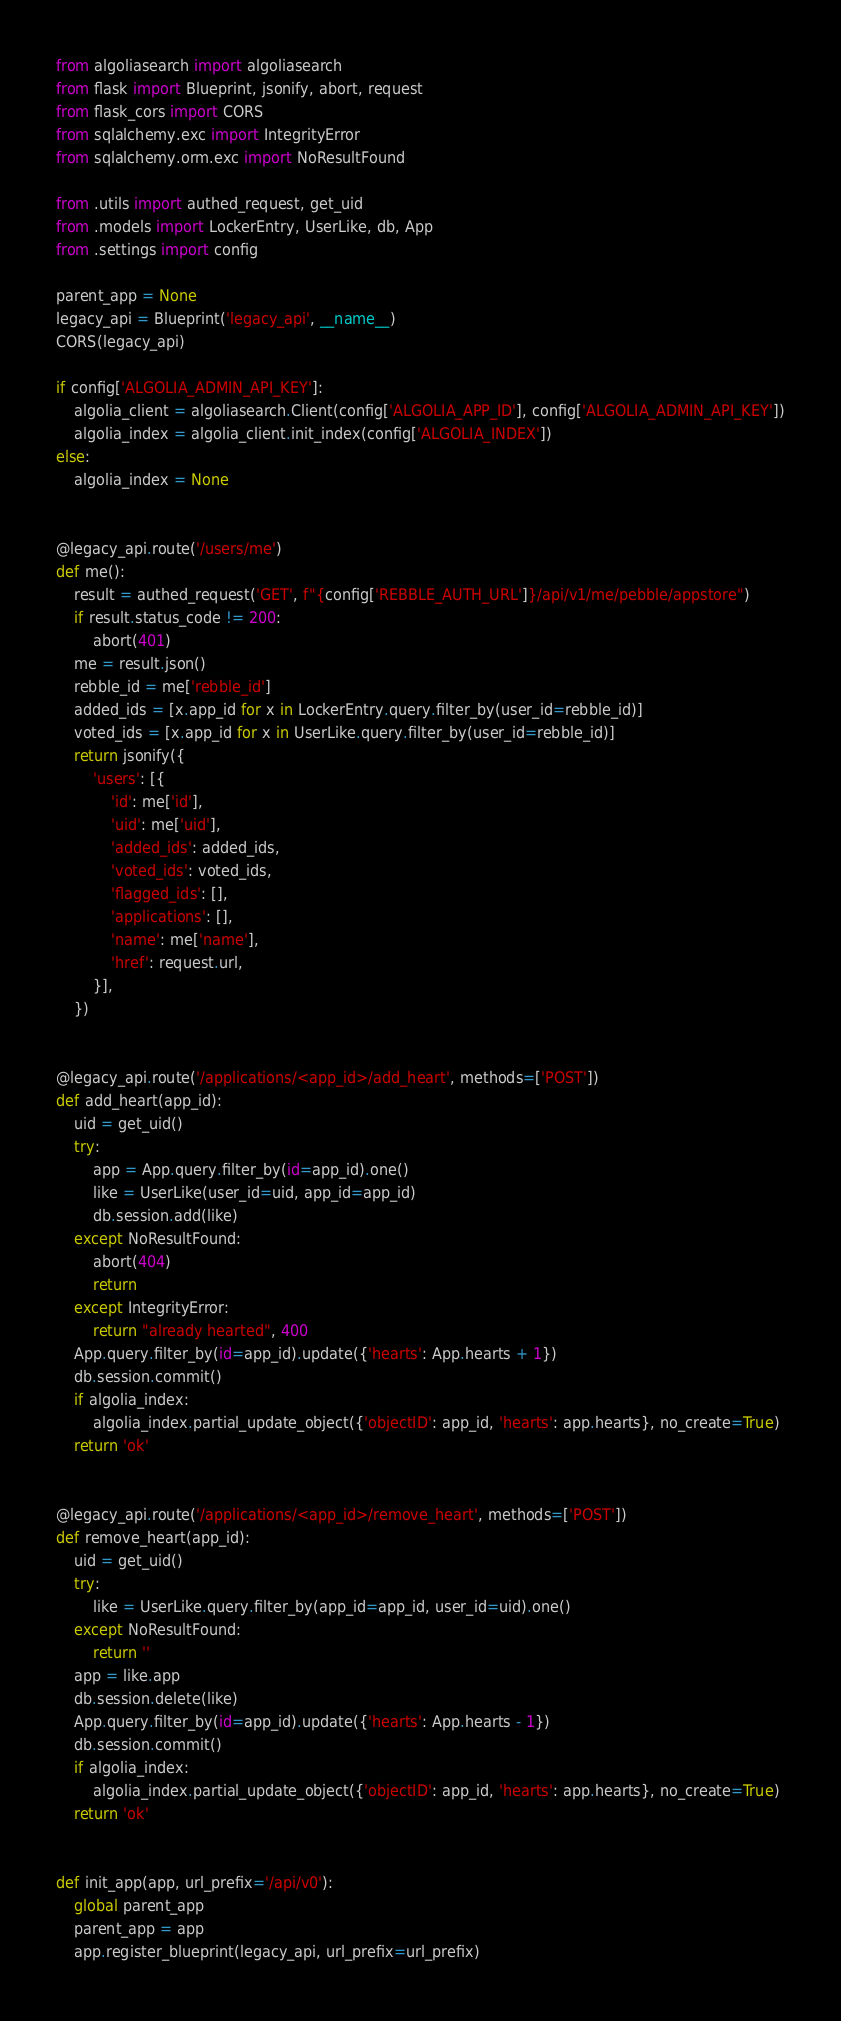<code> <loc_0><loc_0><loc_500><loc_500><_Python_>from algoliasearch import algoliasearch
from flask import Blueprint, jsonify, abort, request
from flask_cors import CORS
from sqlalchemy.exc import IntegrityError
from sqlalchemy.orm.exc import NoResultFound

from .utils import authed_request, get_uid
from .models import LockerEntry, UserLike, db, App
from .settings import config

parent_app = None
legacy_api = Blueprint('legacy_api', __name__)
CORS(legacy_api)

if config['ALGOLIA_ADMIN_API_KEY']:
    algolia_client = algoliasearch.Client(config['ALGOLIA_APP_ID'], config['ALGOLIA_ADMIN_API_KEY'])
    algolia_index = algolia_client.init_index(config['ALGOLIA_INDEX'])
else:
    algolia_index = None


@legacy_api.route('/users/me')
def me():
    result = authed_request('GET', f"{config['REBBLE_AUTH_URL']}/api/v1/me/pebble/appstore")
    if result.status_code != 200:
        abort(401)
    me = result.json()
    rebble_id = me['rebble_id']
    added_ids = [x.app_id for x in LockerEntry.query.filter_by(user_id=rebble_id)]
    voted_ids = [x.app_id for x in UserLike.query.filter_by(user_id=rebble_id)]
    return jsonify({
        'users': [{
            'id': me['id'],
            'uid': me['uid'],
            'added_ids': added_ids,
            'voted_ids': voted_ids,
            'flagged_ids': [],
            'applications': [],
            'name': me['name'],
            'href': request.url,
        }],
    })


@legacy_api.route('/applications/<app_id>/add_heart', methods=['POST'])
def add_heart(app_id):
    uid = get_uid()
    try:
        app = App.query.filter_by(id=app_id).one()
        like = UserLike(user_id=uid, app_id=app_id)
        db.session.add(like)
    except NoResultFound:
        abort(404)
        return
    except IntegrityError:
        return "already hearted", 400
    App.query.filter_by(id=app_id).update({'hearts': App.hearts + 1})
    db.session.commit()
    if algolia_index:
        algolia_index.partial_update_object({'objectID': app_id, 'hearts': app.hearts}, no_create=True)
    return 'ok'


@legacy_api.route('/applications/<app_id>/remove_heart', methods=['POST'])
def remove_heart(app_id):
    uid = get_uid()
    try:
        like = UserLike.query.filter_by(app_id=app_id, user_id=uid).one()
    except NoResultFound:
        return ''
    app = like.app
    db.session.delete(like)
    App.query.filter_by(id=app_id).update({'hearts': App.hearts - 1})
    db.session.commit()
    if algolia_index:
        algolia_index.partial_update_object({'objectID': app_id, 'hearts': app.hearts}, no_create=True)
    return 'ok'


def init_app(app, url_prefix='/api/v0'):
    global parent_app
    parent_app = app
    app.register_blueprint(legacy_api, url_prefix=url_prefix)
</code> 